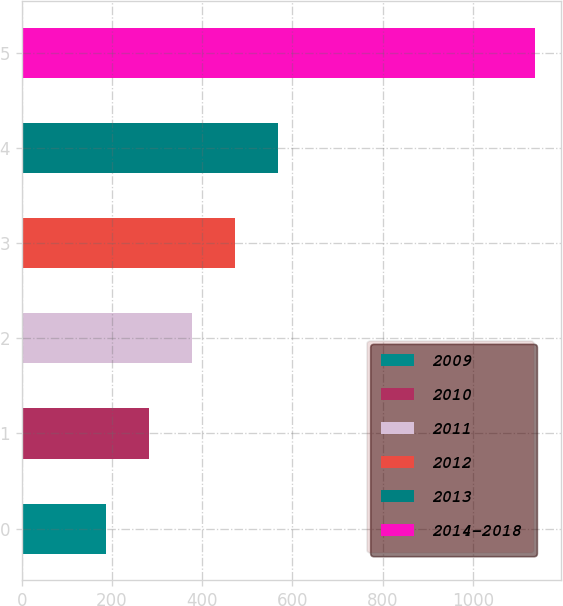Convert chart to OTSL. <chart><loc_0><loc_0><loc_500><loc_500><bar_chart><fcel>2009<fcel>2010<fcel>2011<fcel>2012<fcel>2013<fcel>2014-2018<nl><fcel>186.9<fcel>282.03<fcel>377.16<fcel>472.29<fcel>567.42<fcel>1138.2<nl></chart> 